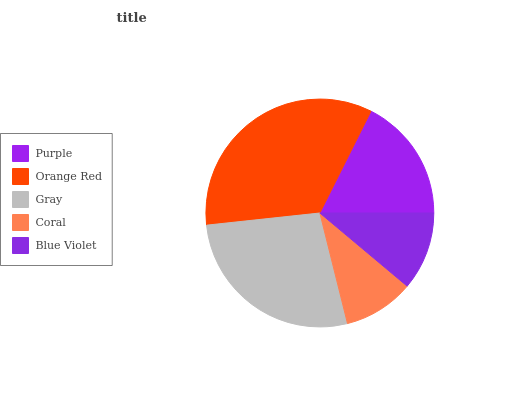Is Coral the minimum?
Answer yes or no. Yes. Is Orange Red the maximum?
Answer yes or no. Yes. Is Gray the minimum?
Answer yes or no. No. Is Gray the maximum?
Answer yes or no. No. Is Orange Red greater than Gray?
Answer yes or no. Yes. Is Gray less than Orange Red?
Answer yes or no. Yes. Is Gray greater than Orange Red?
Answer yes or no. No. Is Orange Red less than Gray?
Answer yes or no. No. Is Purple the high median?
Answer yes or no. Yes. Is Purple the low median?
Answer yes or no. Yes. Is Blue Violet the high median?
Answer yes or no. No. Is Orange Red the low median?
Answer yes or no. No. 